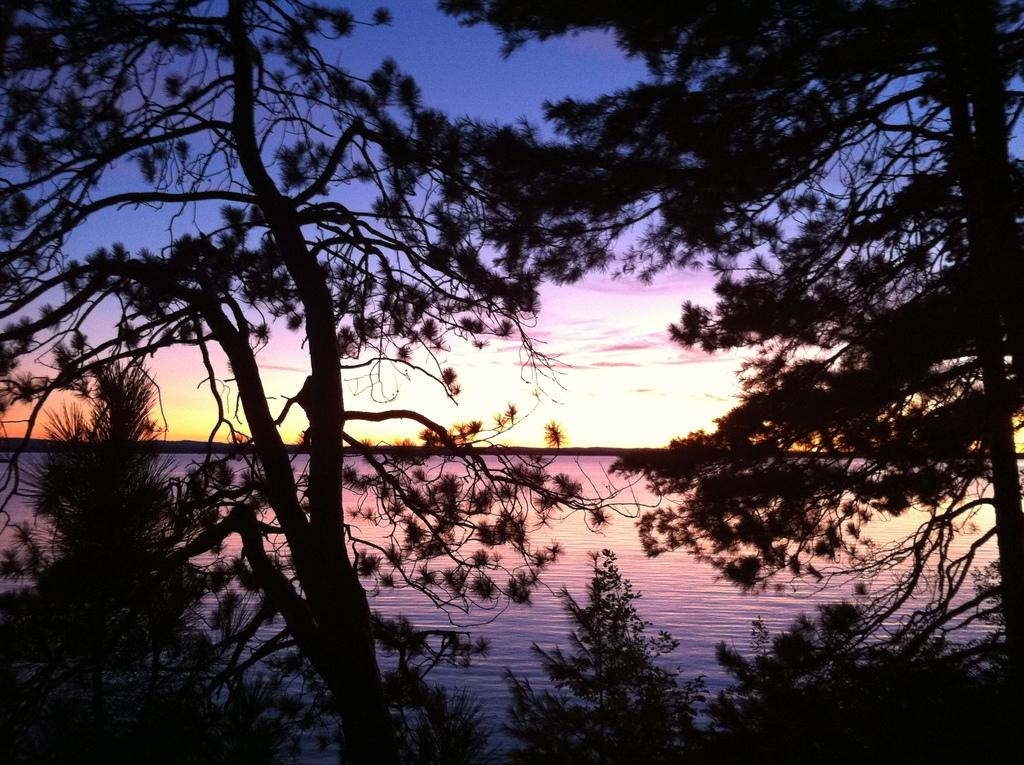What type of vegetation can be seen in the image? There are trees in the image. What natural element is visible in the image besides trees? There is water visible in the image. What part of the sky is visible in the image? The sky is visible in the image. What can be observed in the sky? Clouds are present in the sky. How many pizzas are being served by the fowl in the image? There are no pizzas or fowl present in the image. 